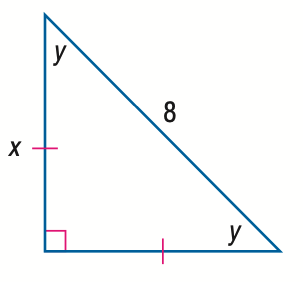Answer the mathemtical geometry problem and directly provide the correct option letter.
Question: Find x.
Choices: A: 4 B: 4 \sqrt { 2 } C: 4 \sqrt { 3 } D: 8 B 